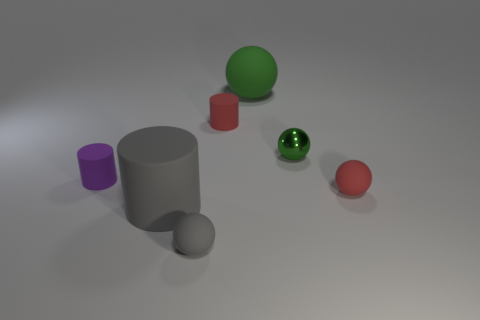What is the material of the object that is the same color as the metallic ball?
Offer a terse response. Rubber. Does the gray cylinder have the same size as the green rubber thing?
Provide a short and direct response. Yes. Is there any other thing that is the same size as the gray sphere?
Keep it short and to the point. Yes. There is a small object left of the small gray rubber thing; is it the same shape as the big object in front of the small red matte cylinder?
Ensure brevity in your answer.  Yes. The red sphere has what size?
Make the answer very short. Small. There is a small cylinder to the left of the sphere in front of the small matte sphere on the right side of the small shiny ball; what is it made of?
Ensure brevity in your answer.  Rubber. How many other objects are the same color as the tiny metallic thing?
Provide a succinct answer. 1. What number of red objects are either cylinders or small matte spheres?
Offer a terse response. 2. What is the green thing on the right side of the green rubber ball made of?
Your response must be concise. Metal. Is the tiny red object that is on the left side of the big green matte sphere made of the same material as the tiny green ball?
Keep it short and to the point. No. 